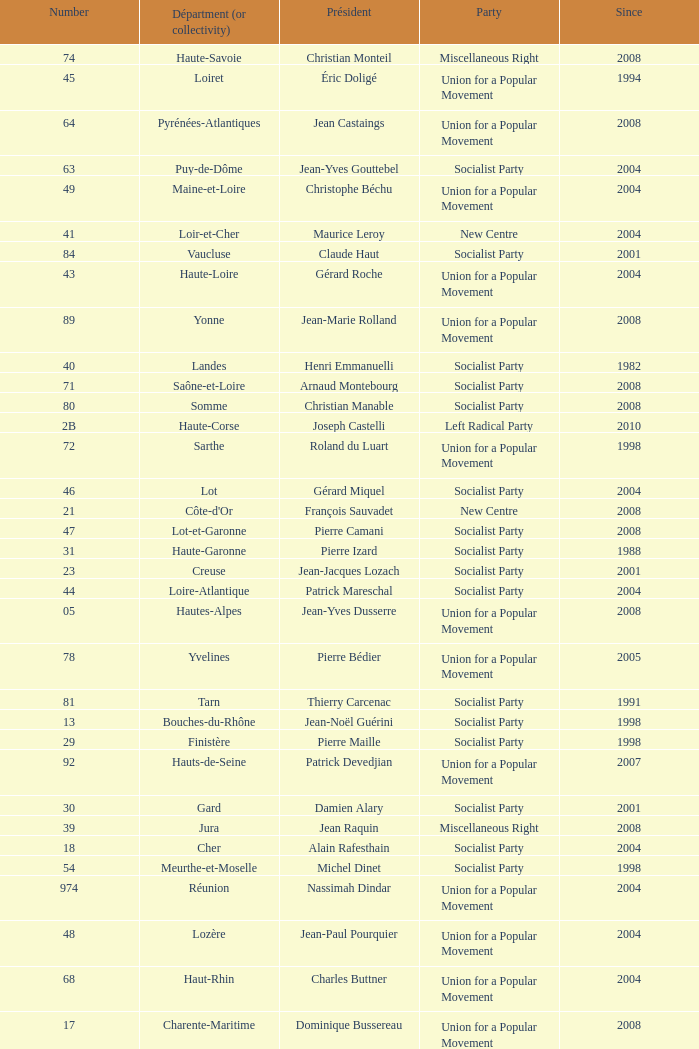Who is the president representing the Creuse department? Jean-Jacques Lozach. 